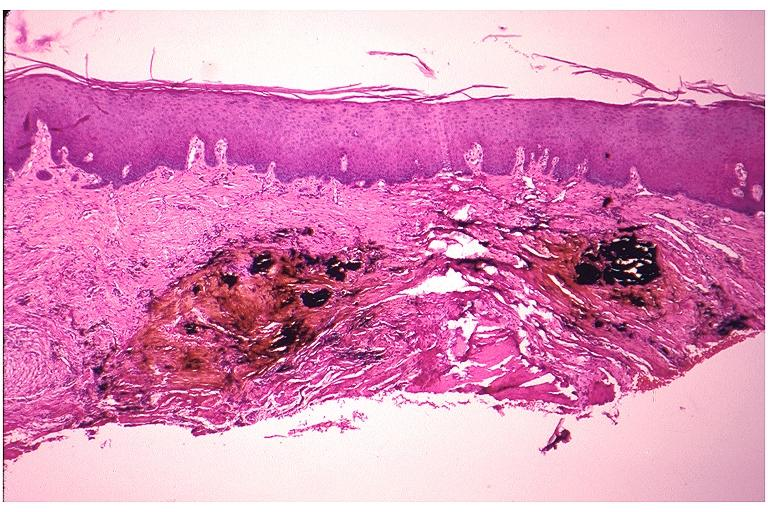s omentum present?
Answer the question using a single word or phrase. No 